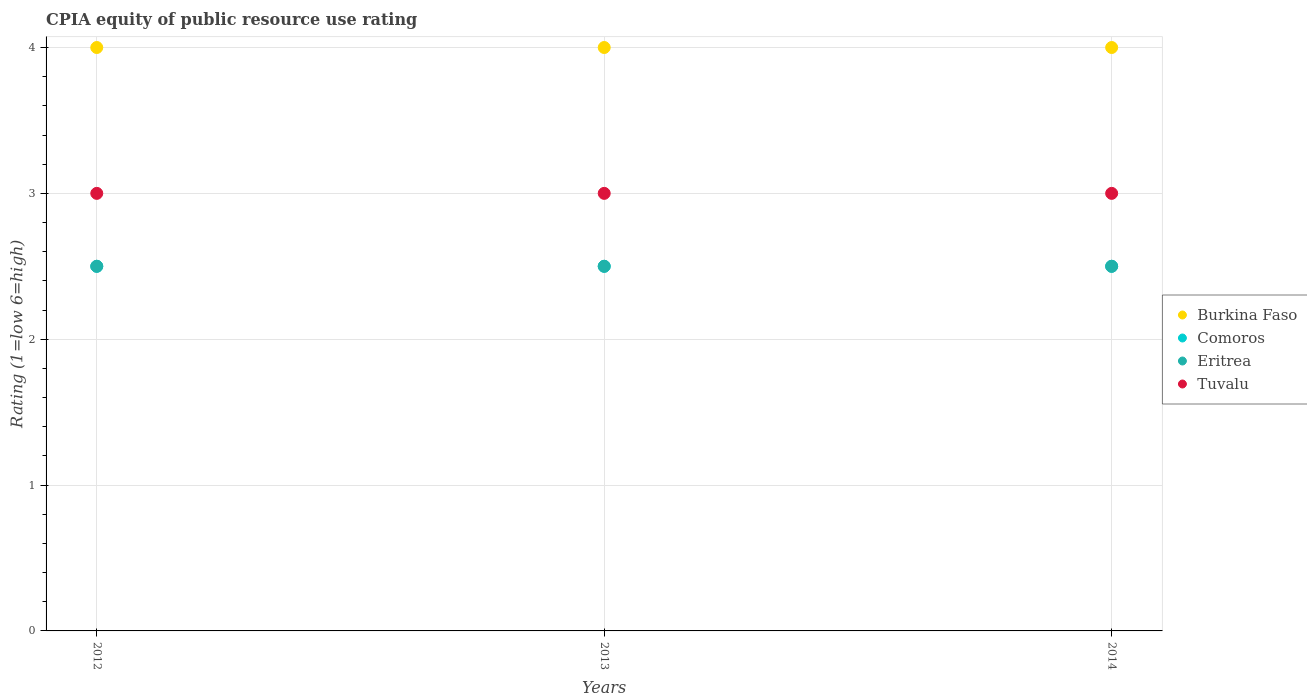Is the number of dotlines equal to the number of legend labels?
Give a very brief answer. Yes. What is the CPIA rating in Eritrea in 2012?
Keep it short and to the point. 2.5. In which year was the CPIA rating in Comoros maximum?
Provide a succinct answer. 2012. In which year was the CPIA rating in Tuvalu minimum?
Provide a succinct answer. 2012. What is the total CPIA rating in Burkina Faso in the graph?
Offer a very short reply. 12. What is the difference between the CPIA rating in Tuvalu in 2012 and that in 2014?
Provide a succinct answer. 0. What is the average CPIA rating in Tuvalu per year?
Your response must be concise. 3. In how many years, is the CPIA rating in Tuvalu greater than 2.6?
Offer a very short reply. 3. Is the CPIA rating in Eritrea in 2012 less than that in 2013?
Offer a terse response. No. Is the sum of the CPIA rating in Comoros in 2013 and 2014 greater than the maximum CPIA rating in Tuvalu across all years?
Your answer should be compact. Yes. Is it the case that in every year, the sum of the CPIA rating in Comoros and CPIA rating in Tuvalu  is greater than the sum of CPIA rating in Eritrea and CPIA rating in Burkina Faso?
Your response must be concise. No. Is it the case that in every year, the sum of the CPIA rating in Tuvalu and CPIA rating in Eritrea  is greater than the CPIA rating in Comoros?
Your answer should be compact. Yes. Does the CPIA rating in Tuvalu monotonically increase over the years?
Ensure brevity in your answer.  No. Is the CPIA rating in Comoros strictly less than the CPIA rating in Burkina Faso over the years?
Provide a short and direct response. Yes. How many dotlines are there?
Your answer should be very brief. 4. How many years are there in the graph?
Keep it short and to the point. 3. What is the difference between two consecutive major ticks on the Y-axis?
Offer a very short reply. 1. Are the values on the major ticks of Y-axis written in scientific E-notation?
Give a very brief answer. No. Where does the legend appear in the graph?
Your answer should be very brief. Center right. What is the title of the graph?
Give a very brief answer. CPIA equity of public resource use rating. What is the label or title of the Y-axis?
Provide a succinct answer. Rating (1=low 6=high). What is the Rating (1=low 6=high) in Comoros in 2012?
Keep it short and to the point. 2.5. What is the Rating (1=low 6=high) of Tuvalu in 2012?
Make the answer very short. 3. What is the Rating (1=low 6=high) in Comoros in 2013?
Your response must be concise. 2.5. What is the Rating (1=low 6=high) in Tuvalu in 2013?
Make the answer very short. 3. What is the Rating (1=low 6=high) in Eritrea in 2014?
Keep it short and to the point. 2.5. What is the Rating (1=low 6=high) of Tuvalu in 2014?
Offer a very short reply. 3. Across all years, what is the maximum Rating (1=low 6=high) in Burkina Faso?
Keep it short and to the point. 4. Across all years, what is the maximum Rating (1=low 6=high) of Tuvalu?
Keep it short and to the point. 3. Across all years, what is the minimum Rating (1=low 6=high) in Burkina Faso?
Provide a short and direct response. 4. What is the total Rating (1=low 6=high) of Burkina Faso in the graph?
Make the answer very short. 12. What is the total Rating (1=low 6=high) of Comoros in the graph?
Your answer should be compact. 7.5. What is the total Rating (1=low 6=high) in Eritrea in the graph?
Keep it short and to the point. 7.5. What is the difference between the Rating (1=low 6=high) of Comoros in 2012 and that in 2013?
Your answer should be very brief. 0. What is the difference between the Rating (1=low 6=high) in Tuvalu in 2012 and that in 2013?
Your answer should be very brief. 0. What is the difference between the Rating (1=low 6=high) of Eritrea in 2012 and that in 2014?
Your response must be concise. 0. What is the difference between the Rating (1=low 6=high) in Eritrea in 2013 and that in 2014?
Provide a succinct answer. 0. What is the difference between the Rating (1=low 6=high) in Burkina Faso in 2012 and the Rating (1=low 6=high) in Eritrea in 2013?
Provide a short and direct response. 1.5. What is the difference between the Rating (1=low 6=high) of Burkina Faso in 2012 and the Rating (1=low 6=high) of Tuvalu in 2013?
Your answer should be compact. 1. What is the difference between the Rating (1=low 6=high) in Comoros in 2012 and the Rating (1=low 6=high) in Eritrea in 2013?
Ensure brevity in your answer.  0. What is the difference between the Rating (1=low 6=high) of Comoros in 2012 and the Rating (1=low 6=high) of Tuvalu in 2013?
Ensure brevity in your answer.  -0.5. What is the difference between the Rating (1=low 6=high) of Eritrea in 2012 and the Rating (1=low 6=high) of Tuvalu in 2013?
Ensure brevity in your answer.  -0.5. What is the difference between the Rating (1=low 6=high) in Burkina Faso in 2012 and the Rating (1=low 6=high) in Comoros in 2014?
Ensure brevity in your answer.  1.5. What is the difference between the Rating (1=low 6=high) of Comoros in 2012 and the Rating (1=low 6=high) of Eritrea in 2014?
Make the answer very short. 0. What is the difference between the Rating (1=low 6=high) in Comoros in 2012 and the Rating (1=low 6=high) in Tuvalu in 2014?
Your answer should be very brief. -0.5. What is the difference between the Rating (1=low 6=high) in Burkina Faso in 2013 and the Rating (1=low 6=high) in Comoros in 2014?
Give a very brief answer. 1.5. What is the difference between the Rating (1=low 6=high) in Comoros in 2013 and the Rating (1=low 6=high) in Eritrea in 2014?
Ensure brevity in your answer.  0. What is the difference between the Rating (1=low 6=high) of Comoros in 2013 and the Rating (1=low 6=high) of Tuvalu in 2014?
Keep it short and to the point. -0.5. What is the average Rating (1=low 6=high) of Comoros per year?
Provide a short and direct response. 2.5. What is the average Rating (1=low 6=high) in Eritrea per year?
Your answer should be very brief. 2.5. What is the average Rating (1=low 6=high) of Tuvalu per year?
Your response must be concise. 3. In the year 2012, what is the difference between the Rating (1=low 6=high) in Burkina Faso and Rating (1=low 6=high) in Comoros?
Your response must be concise. 1.5. In the year 2012, what is the difference between the Rating (1=low 6=high) in Burkina Faso and Rating (1=low 6=high) in Tuvalu?
Offer a terse response. 1. In the year 2013, what is the difference between the Rating (1=low 6=high) in Burkina Faso and Rating (1=low 6=high) in Eritrea?
Offer a terse response. 1.5. In the year 2013, what is the difference between the Rating (1=low 6=high) in Burkina Faso and Rating (1=low 6=high) in Tuvalu?
Your answer should be very brief. 1. In the year 2013, what is the difference between the Rating (1=low 6=high) in Comoros and Rating (1=low 6=high) in Eritrea?
Make the answer very short. 0. In the year 2013, what is the difference between the Rating (1=low 6=high) of Comoros and Rating (1=low 6=high) of Tuvalu?
Provide a succinct answer. -0.5. In the year 2014, what is the difference between the Rating (1=low 6=high) of Burkina Faso and Rating (1=low 6=high) of Eritrea?
Keep it short and to the point. 1.5. In the year 2014, what is the difference between the Rating (1=low 6=high) of Burkina Faso and Rating (1=low 6=high) of Tuvalu?
Your response must be concise. 1. In the year 2014, what is the difference between the Rating (1=low 6=high) of Eritrea and Rating (1=low 6=high) of Tuvalu?
Your response must be concise. -0.5. What is the ratio of the Rating (1=low 6=high) of Burkina Faso in 2012 to that in 2013?
Make the answer very short. 1. What is the ratio of the Rating (1=low 6=high) of Comoros in 2012 to that in 2013?
Your answer should be very brief. 1. What is the ratio of the Rating (1=low 6=high) in Eritrea in 2012 to that in 2013?
Keep it short and to the point. 1. What is the ratio of the Rating (1=low 6=high) in Tuvalu in 2012 to that in 2013?
Keep it short and to the point. 1. What is the ratio of the Rating (1=low 6=high) of Burkina Faso in 2012 to that in 2014?
Keep it short and to the point. 1. What is the ratio of the Rating (1=low 6=high) of Eritrea in 2012 to that in 2014?
Keep it short and to the point. 1. What is the ratio of the Rating (1=low 6=high) in Tuvalu in 2012 to that in 2014?
Offer a very short reply. 1. What is the difference between the highest and the second highest Rating (1=low 6=high) of Eritrea?
Your answer should be compact. 0. What is the difference between the highest and the second highest Rating (1=low 6=high) in Tuvalu?
Ensure brevity in your answer.  0. What is the difference between the highest and the lowest Rating (1=low 6=high) in Burkina Faso?
Offer a terse response. 0. What is the difference between the highest and the lowest Rating (1=low 6=high) of Comoros?
Make the answer very short. 0. What is the difference between the highest and the lowest Rating (1=low 6=high) of Eritrea?
Provide a succinct answer. 0. 